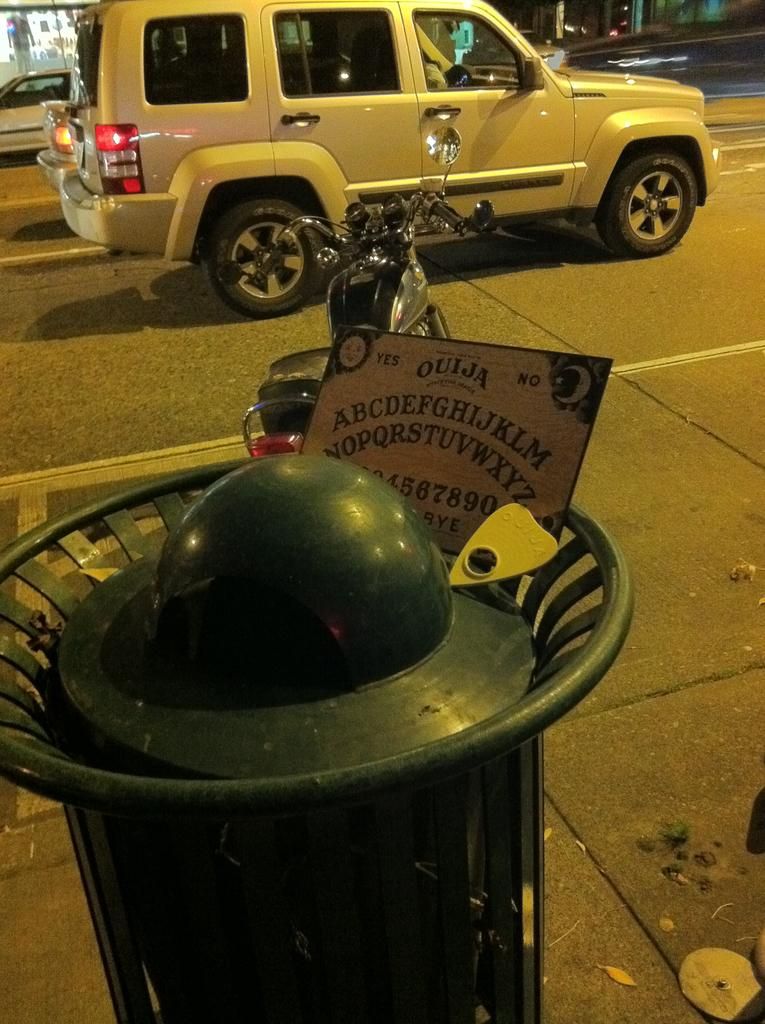What type of container is in the image? There is a bin in the image. What other object can be seen in the image? There is a board in the image. What is happening on the road in the image? Vehicles are present on the road in the image. How much money is being exchanged on the board in the image? There is no money or exchange of money depicted on the board in the image. 